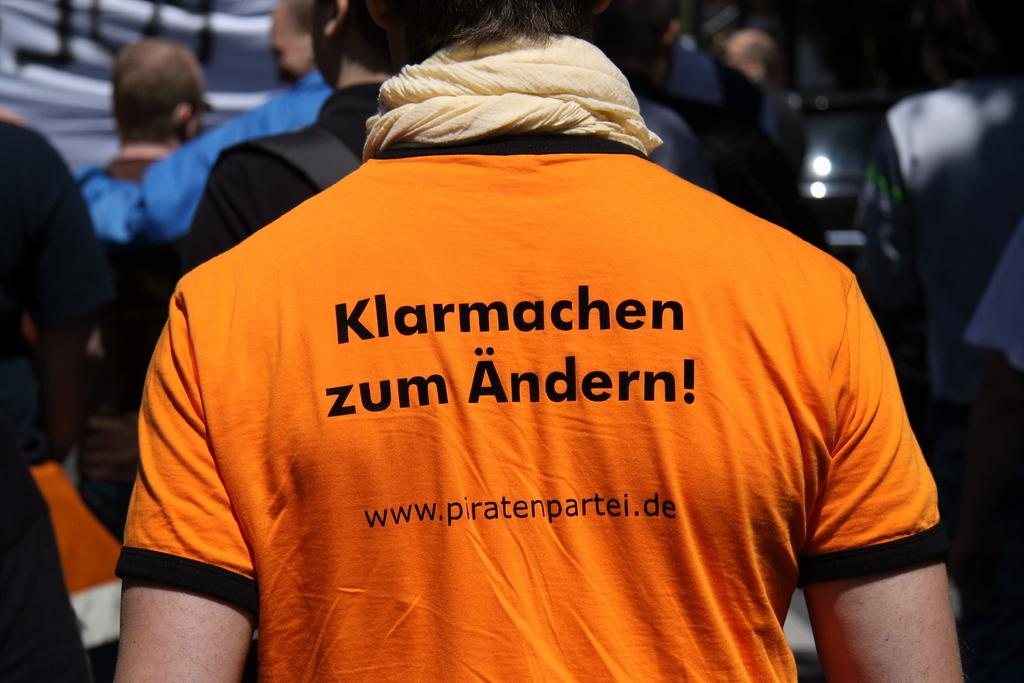<image>
Render a clear and concise summary of the photo. A person has an orange shirt on with the words Klarmachen zum Andern on it. 